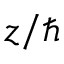Convert formula to latex. <formula><loc_0><loc_0><loc_500><loc_500>z / \hbar</formula> 